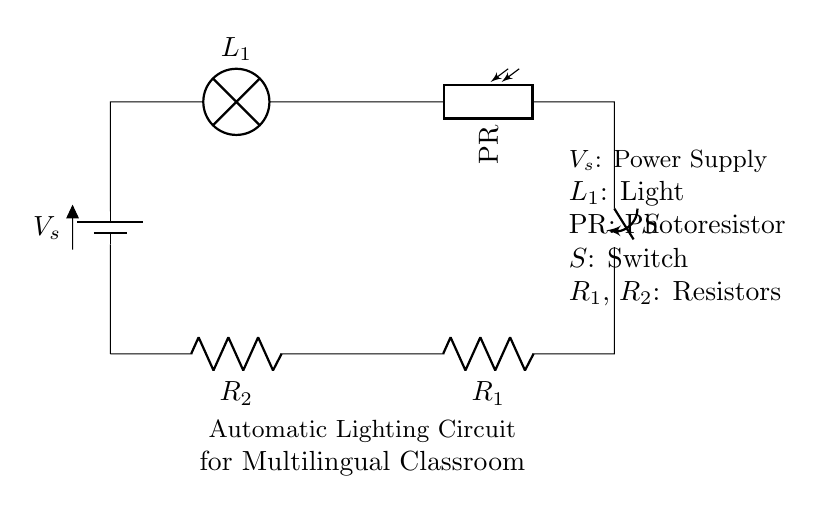What are the main components of this circuit? The circuit consists of a battery, a lamp, a photoresistor, a switch, and two resistors. These components are essential for the automatic lighting functionality.
Answer: battery, lamp, photoresistor, switch, resistors What does the photoresistor do in this circuit? The photoresistor detects light levels, allowing the circuit to turn the lamp on or off based on ambient light conditions. Its resistance changes with light intensity.
Answer: detects light What type of circuit configuration is this? The circuit is a series configuration, meaning all components are connected in a single path, which transfers current uniformly through each component.
Answer: series What happens to the lamp when light falls on the photoresistor? When light falls on the photoresistor, its resistance decreases, allowing more current to flow, which turns on the lamp. This facilitates automatic lighting in the classroom.
Answer: turns on If the switch is closed, what is the effect on the circuit? Closing the switch completes the circuit loop, allowing current to flow through and activating all components, including the lamp based on the photoresistor's conditions.
Answer: activates circuit How does the use of resistors affect the circuit's functionality? The resistors limit the current flowing through the circuit, ensuring that components operate within safe parameters and preventing overload, thus contributing to stable functionality.
Answer: limits current 